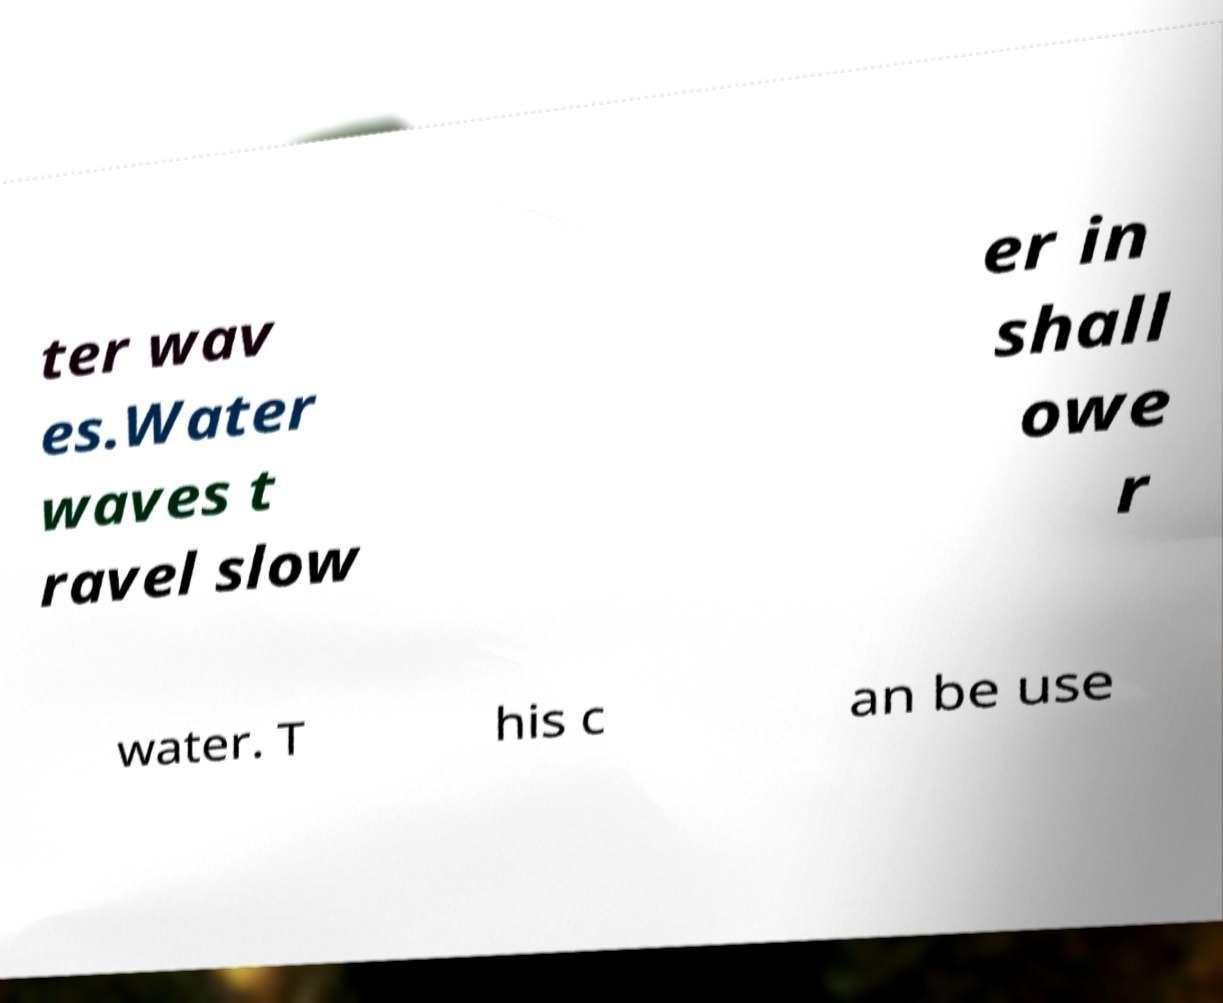Please identify and transcribe the text found in this image. ter wav es.Water waves t ravel slow er in shall owe r water. T his c an be use 